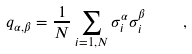<formula> <loc_0><loc_0><loc_500><loc_500>q _ { \alpha , \beta } = \frac { 1 } { N } \sum _ { i = 1 , N } \sigma ^ { \alpha } _ { i } \sigma ^ { \beta } _ { i } \quad ,</formula> 